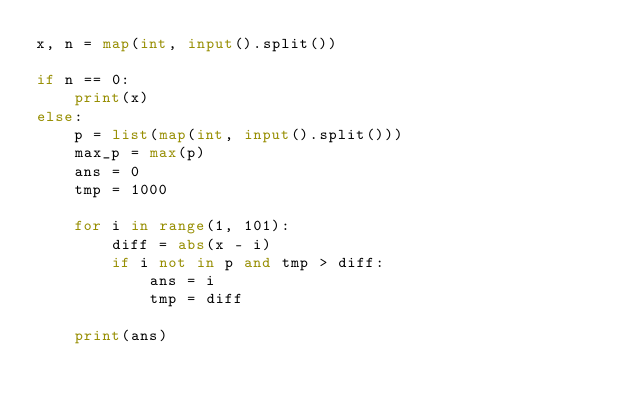<code> <loc_0><loc_0><loc_500><loc_500><_Python_>x, n = map(int, input().split())

if n == 0:    
    print(x)
else:
    p = list(map(int, input().split()))
    max_p = max(p)
    ans = 0
    tmp = 1000

    for i in range(1, 101):
        diff = abs(x - i)
        if i not in p and tmp > diff:
            ans = i
            tmp = diff

    print(ans)
</code> 